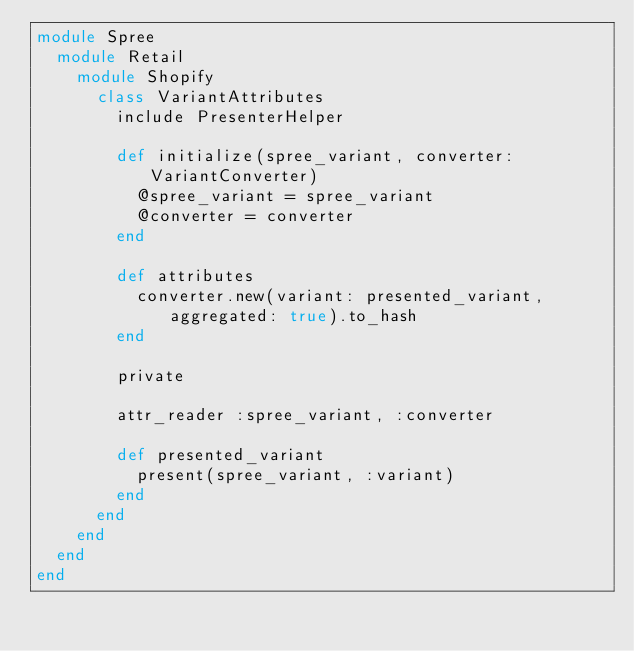Convert code to text. <code><loc_0><loc_0><loc_500><loc_500><_Ruby_>module Spree
  module Retail
    module Shopify
      class VariantAttributes
        include PresenterHelper

        def initialize(spree_variant, converter: VariantConverter)
          @spree_variant = spree_variant
          @converter = converter
        end

        def attributes
          converter.new(variant: presented_variant, aggregated: true).to_hash
        end

        private

        attr_reader :spree_variant, :converter

        def presented_variant
          present(spree_variant, :variant)
        end
      end
    end
  end
end
</code> 